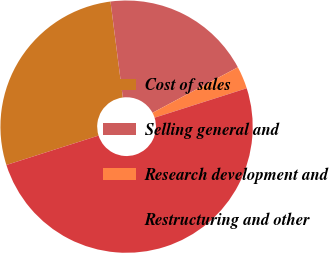Convert chart. <chart><loc_0><loc_0><loc_500><loc_500><pie_chart><fcel>Cost of sales<fcel>Selling general and<fcel>Research development and<fcel>Restructuring and other<nl><fcel>27.88%<fcel>19.23%<fcel>2.88%<fcel>50.0%<nl></chart> 